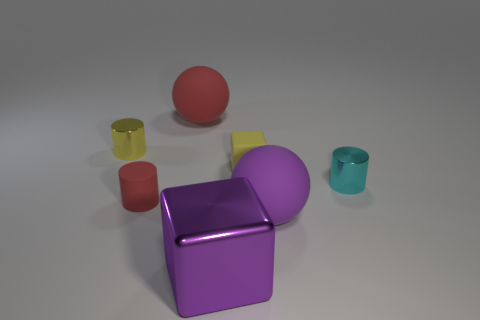There is a big sphere that is on the left side of the big rubber sphere that is in front of the yellow thing that is on the right side of the small yellow cylinder; what color is it?
Provide a succinct answer. Red. The metal object that is behind the big purple metal object and left of the cyan shiny object has what shape?
Offer a very short reply. Cylinder. What number of other objects are the same shape as the big red matte object?
Ensure brevity in your answer.  1. What shape is the small thing on the left side of the red cylinder that is in front of the tiny metal cylinder to the right of the yellow cylinder?
Ensure brevity in your answer.  Cylinder. What number of things are small brown cylinders or balls to the right of the big block?
Offer a very short reply. 1. Does the red rubber thing in front of the big red object have the same shape as the metallic thing behind the cyan metallic thing?
Your response must be concise. Yes. What number of objects are small red metal objects or small metallic cylinders?
Make the answer very short. 2. Are there any small yellow matte cylinders?
Make the answer very short. No. Are the large purple object that is behind the metallic cube and the small red thing made of the same material?
Make the answer very short. Yes. Is there a cyan shiny thing of the same shape as the tiny red object?
Provide a succinct answer. Yes. 